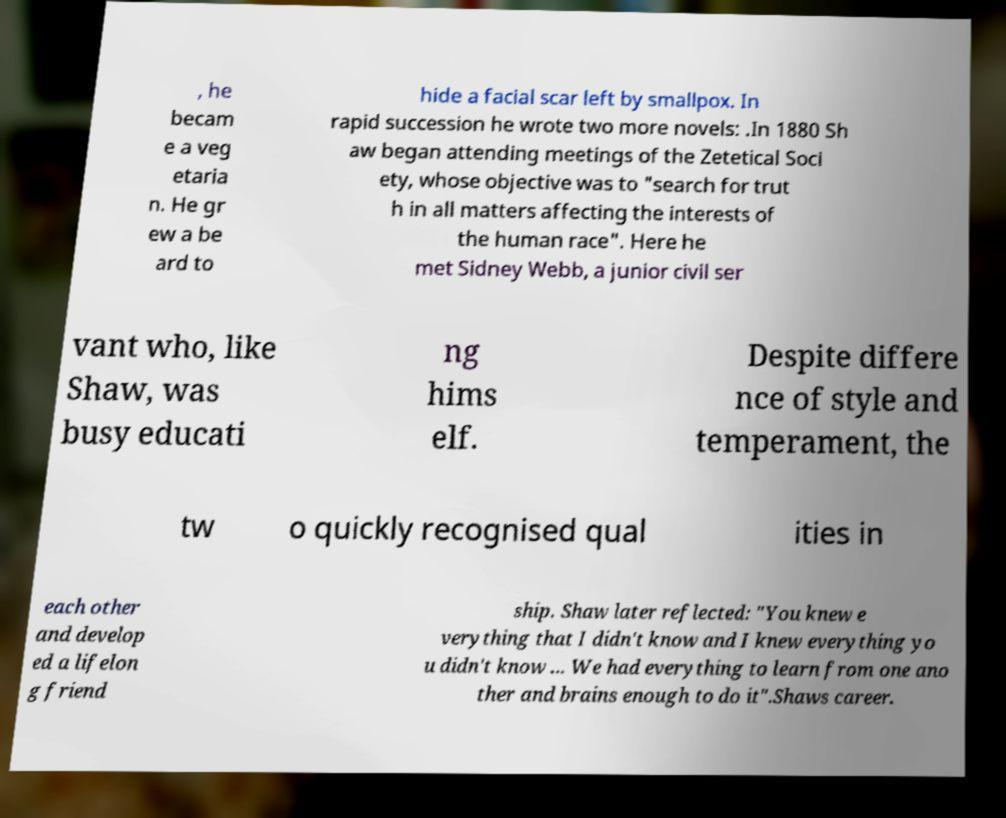Could you extract and type out the text from this image? , he becam e a veg etaria n. He gr ew a be ard to hide a facial scar left by smallpox. In rapid succession he wrote two more novels: .In 1880 Sh aw began attending meetings of the Zetetical Soci ety, whose objective was to "search for trut h in all matters affecting the interests of the human race". Here he met Sidney Webb, a junior civil ser vant who, like Shaw, was busy educati ng hims elf. Despite differe nce of style and temperament, the tw o quickly recognised qual ities in each other and develop ed a lifelon g friend ship. Shaw later reflected: "You knew e verything that I didn't know and I knew everything yo u didn't know ... We had everything to learn from one ano ther and brains enough to do it".Shaws career. 